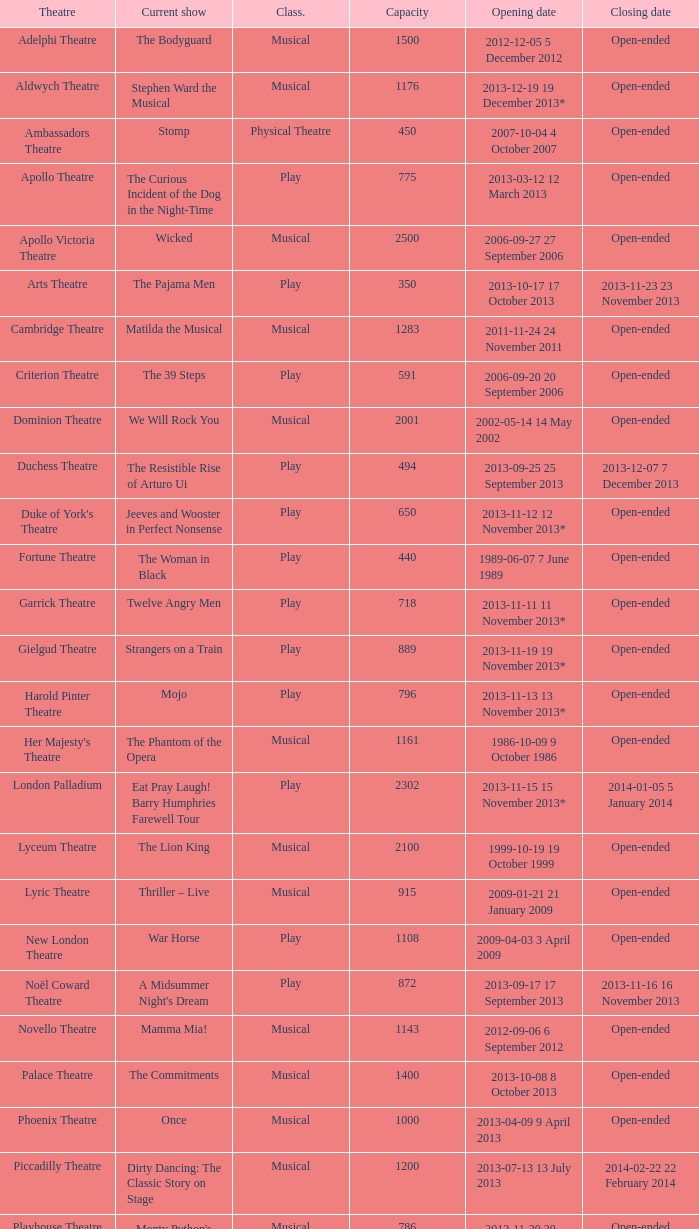What is the opening date of the musical at the adelphi theatre? 2012-12-05 5 December 2012. 